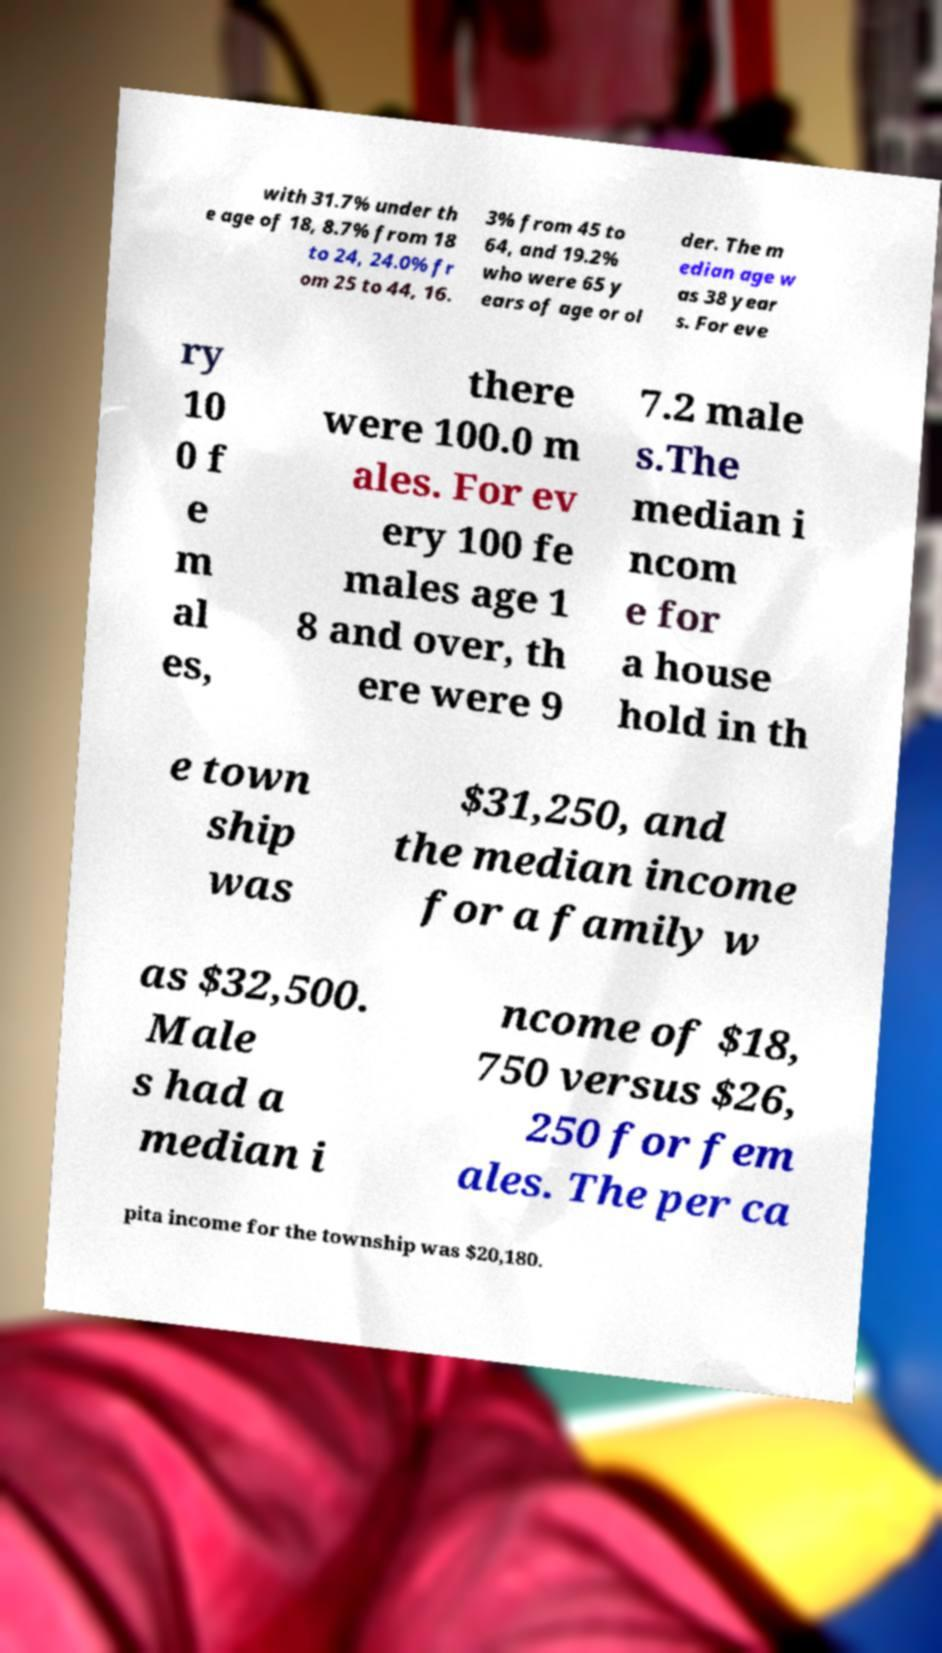Can you accurately transcribe the text from the provided image for me? with 31.7% under th e age of 18, 8.7% from 18 to 24, 24.0% fr om 25 to 44, 16. 3% from 45 to 64, and 19.2% who were 65 y ears of age or ol der. The m edian age w as 38 year s. For eve ry 10 0 f e m al es, there were 100.0 m ales. For ev ery 100 fe males age 1 8 and over, th ere were 9 7.2 male s.The median i ncom e for a house hold in th e town ship was $31,250, and the median income for a family w as $32,500. Male s had a median i ncome of $18, 750 versus $26, 250 for fem ales. The per ca pita income for the township was $20,180. 